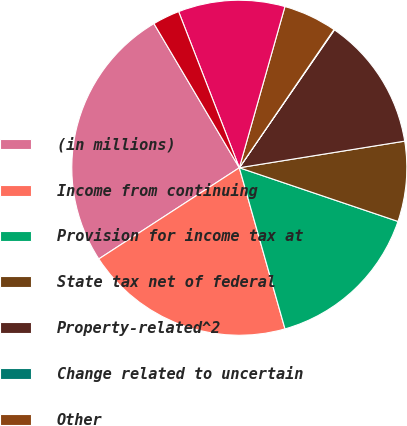Convert chart to OTSL. <chart><loc_0><loc_0><loc_500><loc_500><pie_chart><fcel>(in millions)<fcel>Income from continuing<fcel>Provision for income tax at<fcel>State tax net of federal<fcel>Property-related^2<fcel>Change related to uncertain<fcel>Other<fcel>Total income tax expense<fcel>Effective tax rate<nl><fcel>25.65%<fcel>20.23%<fcel>15.41%<fcel>7.73%<fcel>12.85%<fcel>0.05%<fcel>5.17%<fcel>10.29%<fcel>2.61%<nl></chart> 